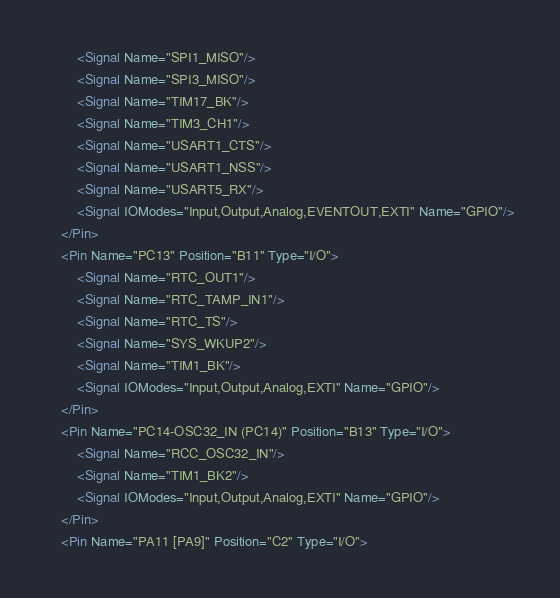Convert code to text. <code><loc_0><loc_0><loc_500><loc_500><_XML_>		<Signal Name="SPI1_MISO"/>
		<Signal Name="SPI3_MISO"/>
		<Signal Name="TIM17_BK"/>
		<Signal Name="TIM3_CH1"/>
		<Signal Name="USART1_CTS"/>
		<Signal Name="USART1_NSS"/>
		<Signal Name="USART5_RX"/>
		<Signal IOModes="Input,Output,Analog,EVENTOUT,EXTI" Name="GPIO"/>
	</Pin>
	<Pin Name="PC13" Position="B11" Type="I/O">
		<Signal Name="RTC_OUT1"/>
		<Signal Name="RTC_TAMP_IN1"/>
		<Signal Name="RTC_TS"/>
		<Signal Name="SYS_WKUP2"/>
		<Signal Name="TIM1_BK"/>
		<Signal IOModes="Input,Output,Analog,EXTI" Name="GPIO"/>
	</Pin>
	<Pin Name="PC14-OSC32_IN (PC14)" Position="B13" Type="I/O">
		<Signal Name="RCC_OSC32_IN"/>
		<Signal Name="TIM1_BK2"/>
		<Signal IOModes="Input,Output,Analog,EXTI" Name="GPIO"/>
	</Pin>
	<Pin Name="PA11 [PA9]" Position="C2" Type="I/O"></code> 